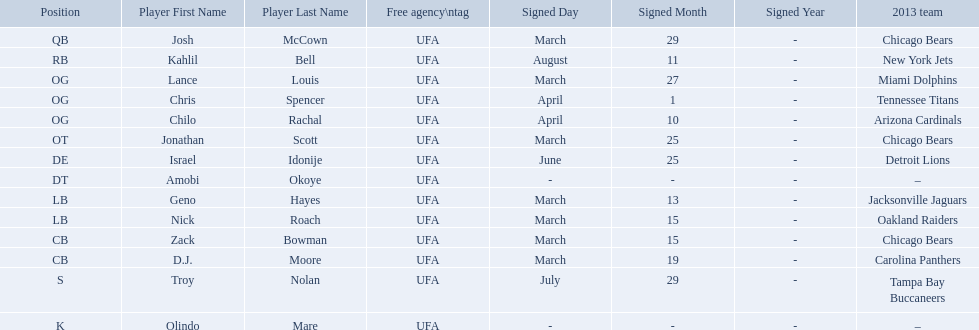What are all the dates signed? March 29, August 11, March 27, April 1, April 10, March 25, June 25, March 13, March 15, March 15, March 19, July 29. Which of these are duplicates? March 15, March 15. Who has the same one as nick roach? Zack Bowman. 